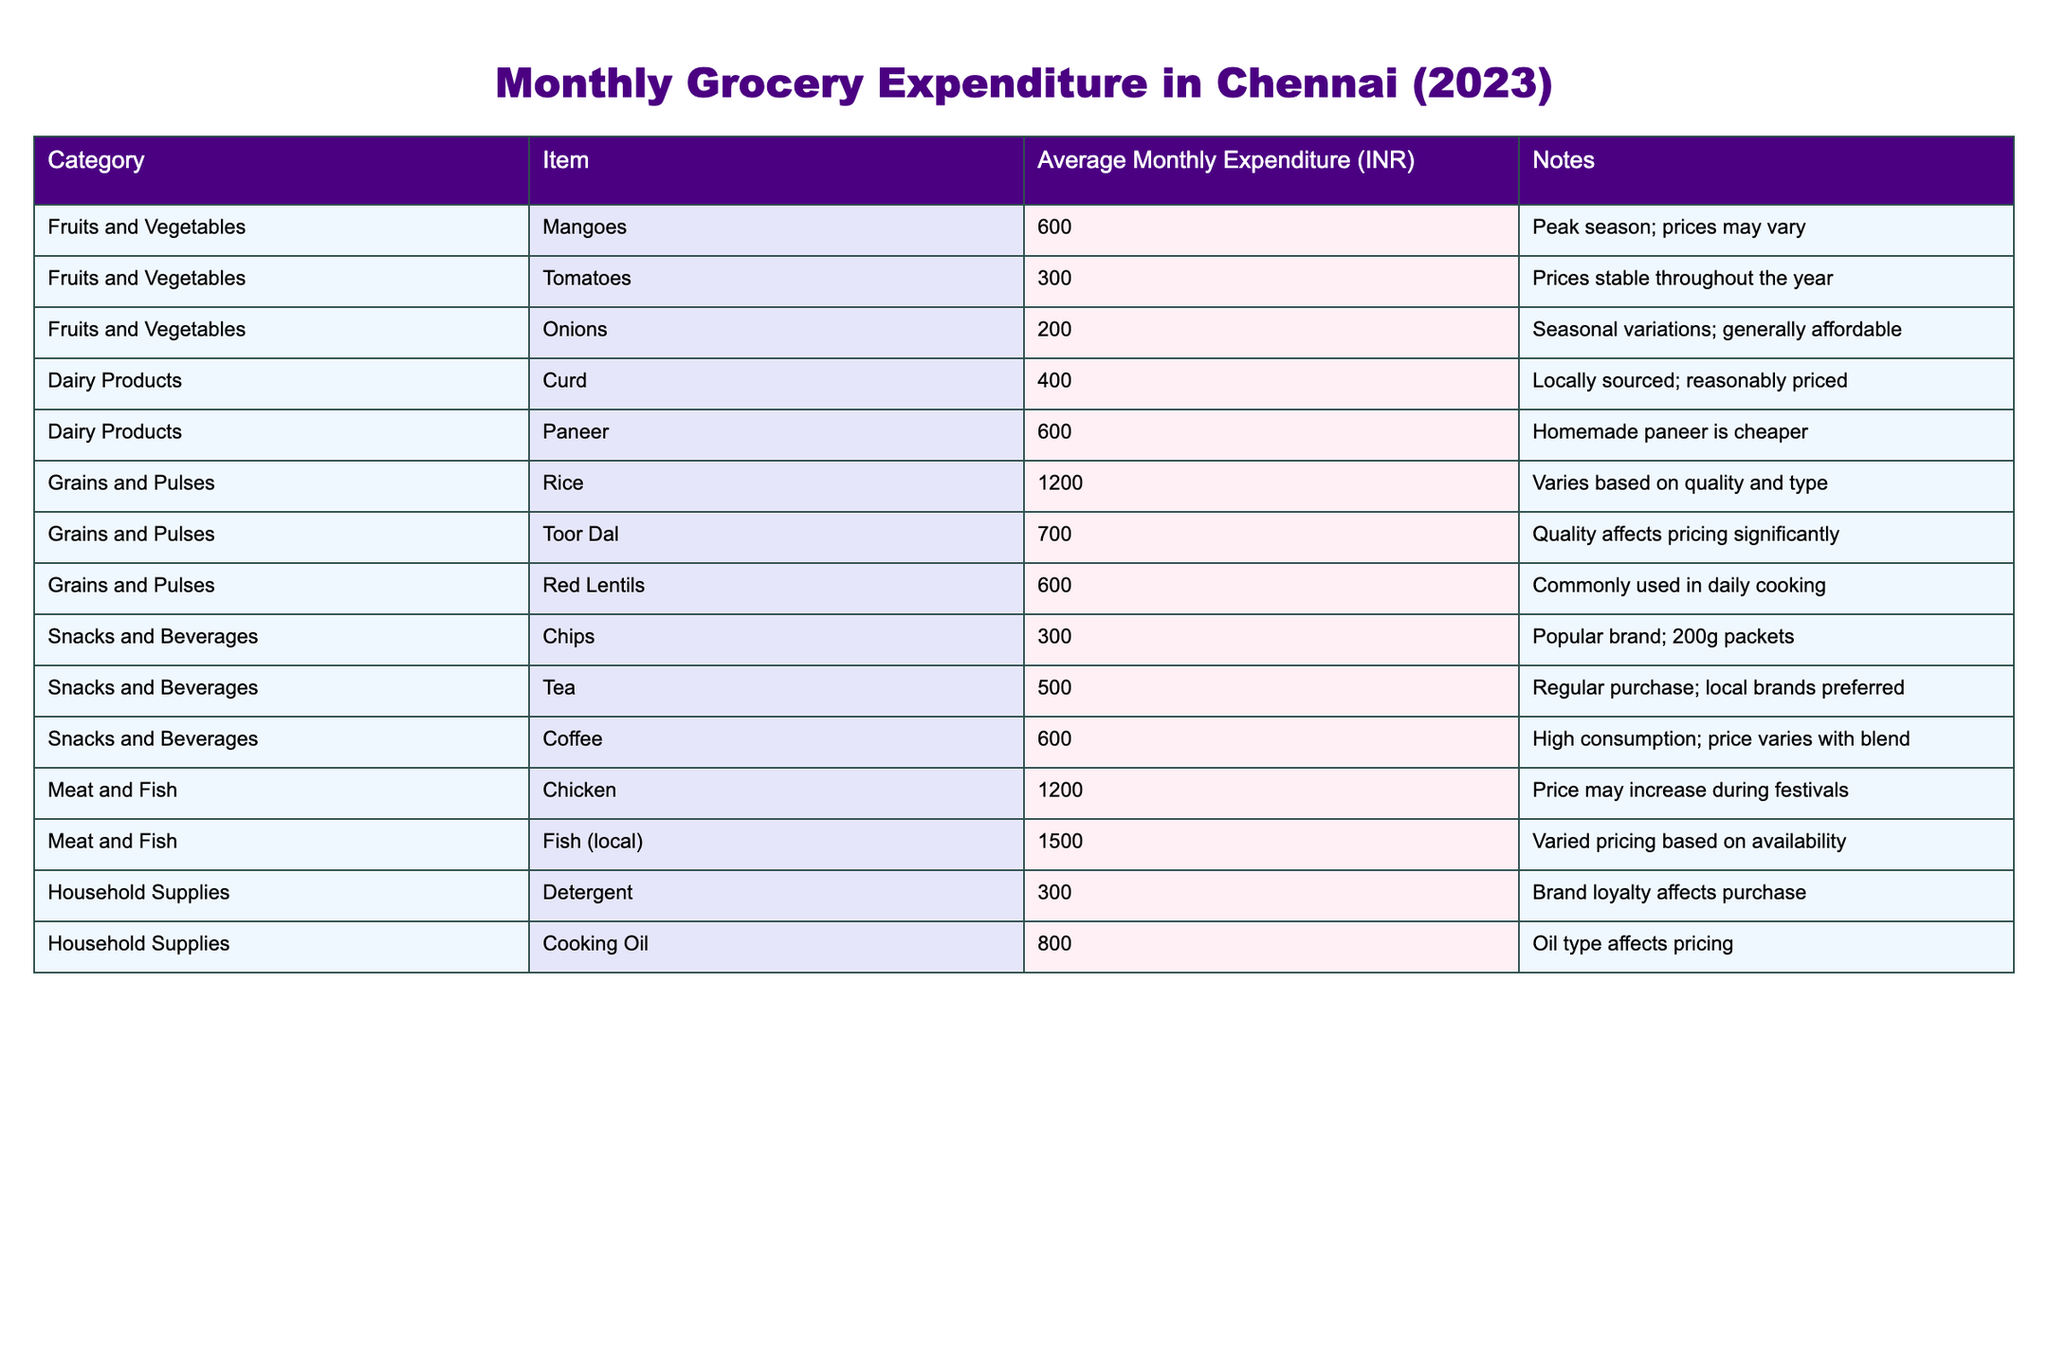What is the average monthly expenditure on Mangoes? The table states that the average monthly expenditure on Mangoes is listed as 600 INR.
Answer: 600 INR Which category has the highest average monthly expenditure? By checking the table, the "Meat and Fish" category has the highest average monthly expenditure on Fish at 1500 INR.
Answer: Meat and Fish What is the total average monthly expenditure for Dairy Products? Adding the expenditures for Curd (400 INR) and Paneer (600 INR) gives us 400 + 600 = 1000 INR.
Answer: 1000 INR Are the prices of Tomatoes stable throughout the year? According to the table, the notes indicate that the prices of Tomatoes are stable throughout the year.
Answer: Yes What is the difference between the average monthly expenditures on Chicken and Curd? The average for Chicken is 1200 INR and for Curd, it is 400 INR. Thus, the difference is 1200 - 400 = 800 INR.
Answer: 800 INR What is the total average monthly expenditure for Snacks and Beverages? The expenditures for Snacks and Beverages are Chips (300 INR), Tea (500 INR), and Coffee (600 INR). Adding them gives: 300 + 500 + 600 = 1400 INR.
Answer: 1400 INR Is the average monthly expenditure on Cooking Oil more than that on Detergent? Cooking Oil costs 800 INR while Detergent costs 300 INR. Since 800 INR is greater than 300 INR, the answer is yes.
Answer: Yes Which item contributes the most to the "Grains and Pulses" category? The item with the highest expenditure in the Grains and Pulses category is Rice, at 1200 INR.
Answer: Rice What is the average expenditure on all Fruits and Vegetables? The expenditures are Mangoes (600 INR), Tomatoes (300 INR), and Onions (200 INR). Adding them gives 600 + 300 + 200 = 1100 INR, then averaging over 3 items gives 1100 / 3 = approximately 366.67 INR.
Answer: 366.67 INR Which two items have the same average monthly expenditure? The items Paneer and Red Lentils both have an average monthly expenditure of 600 INR.
Answer: Paneer and Red Lentils 